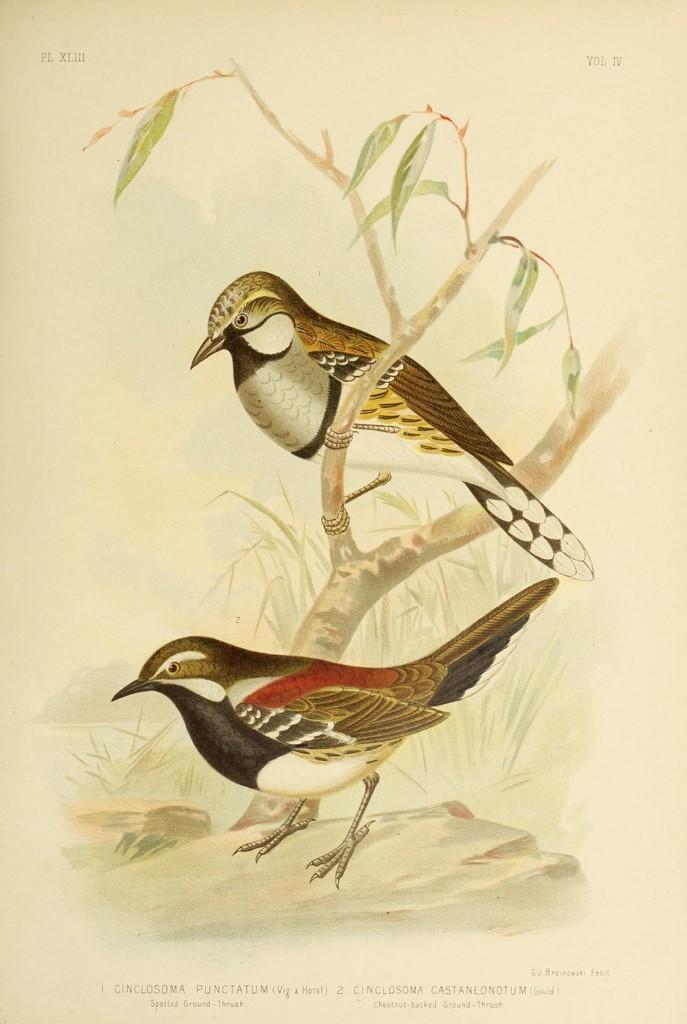Could you give a brief overview of what you see in this image? This is a paper. In this paper something is written. Also there is a painting of birds. One bird is sitting on a branch of a tree. 